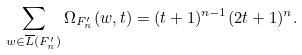<formula> <loc_0><loc_0><loc_500><loc_500>\sum _ { w \in \overline { L } ( F _ { n } ^ { \prime } ) } \Omega _ { F _ { n } ^ { \prime } } ( w , t ) = ( t + 1 ) ^ { n - 1 } ( 2 t + 1 ) ^ { n } .</formula> 